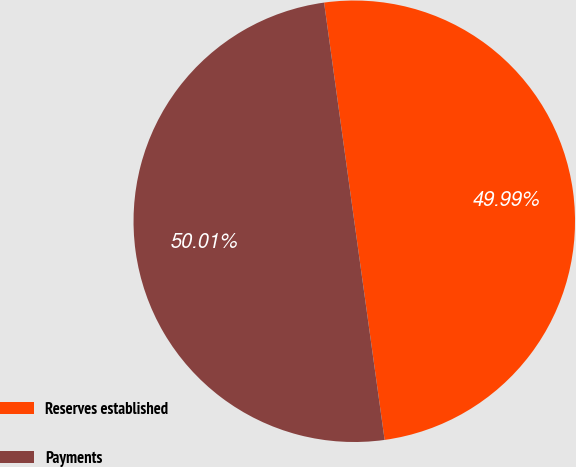Convert chart. <chart><loc_0><loc_0><loc_500><loc_500><pie_chart><fcel>Reserves established<fcel>Payments<nl><fcel>49.99%<fcel>50.01%<nl></chart> 